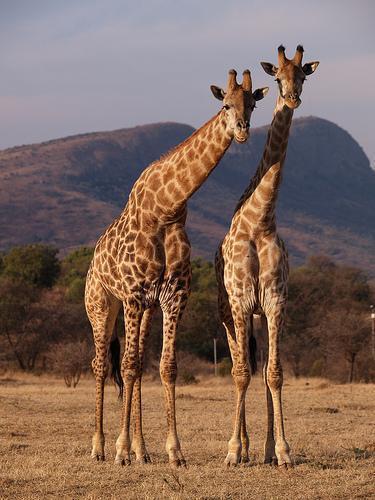How many giraffes are there?
Give a very brief answer. 2. How many giraffes are shown?
Give a very brief answer. 2. 